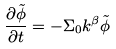Convert formula to latex. <formula><loc_0><loc_0><loc_500><loc_500>\frac { \partial \tilde { \phi } } { \partial t } = - \Sigma _ { 0 } k ^ { \beta } \tilde { \phi }</formula> 